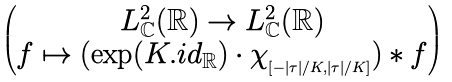<formula> <loc_0><loc_0><loc_500><loc_500>\begin{pmatrix} L ^ { 2 } _ { \mathbb { C } } ( { \mathbb { R } } ) \rightarrow L ^ { 2 } _ { \mathbb { C } } ( { \mathbb { R } } ) \\ f \mapsto ( \exp ( K . { i d } _ { \mathbb { R } } ) \cdot \chi _ { _ { [ - | \tau | / K , | \tau | / K ] } } ) * f \end{pmatrix}</formula> 